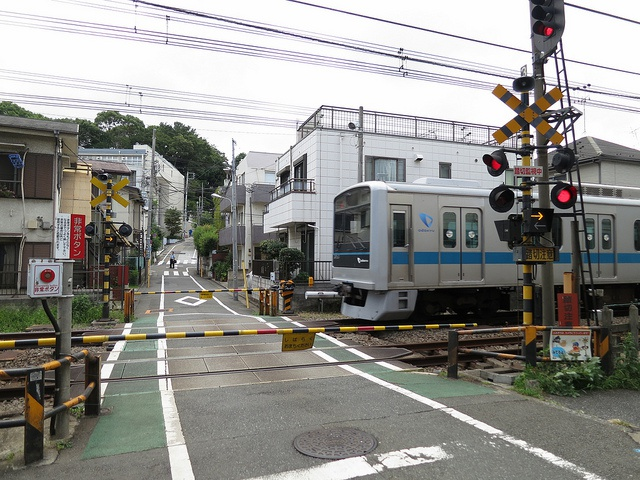Describe the objects in this image and their specific colors. I can see train in white, gray, black, darkgray, and blue tones, traffic light in white, black, and gray tones, traffic light in white, black, darkgray, gray, and lightgray tones, traffic light in white, black, gray, and orange tones, and traffic light in white, black, salmon, maroon, and red tones in this image. 